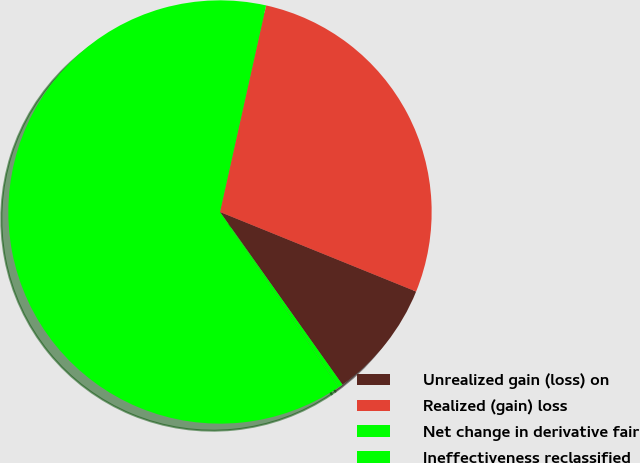Convert chart to OTSL. <chart><loc_0><loc_0><loc_500><loc_500><pie_chart><fcel>Unrealized gain (loss) on<fcel>Realized (gain) loss<fcel>Net change in derivative fair<fcel>Ineffectiveness reclassified<nl><fcel>9.05%<fcel>27.64%<fcel>62.98%<fcel>0.34%<nl></chart> 